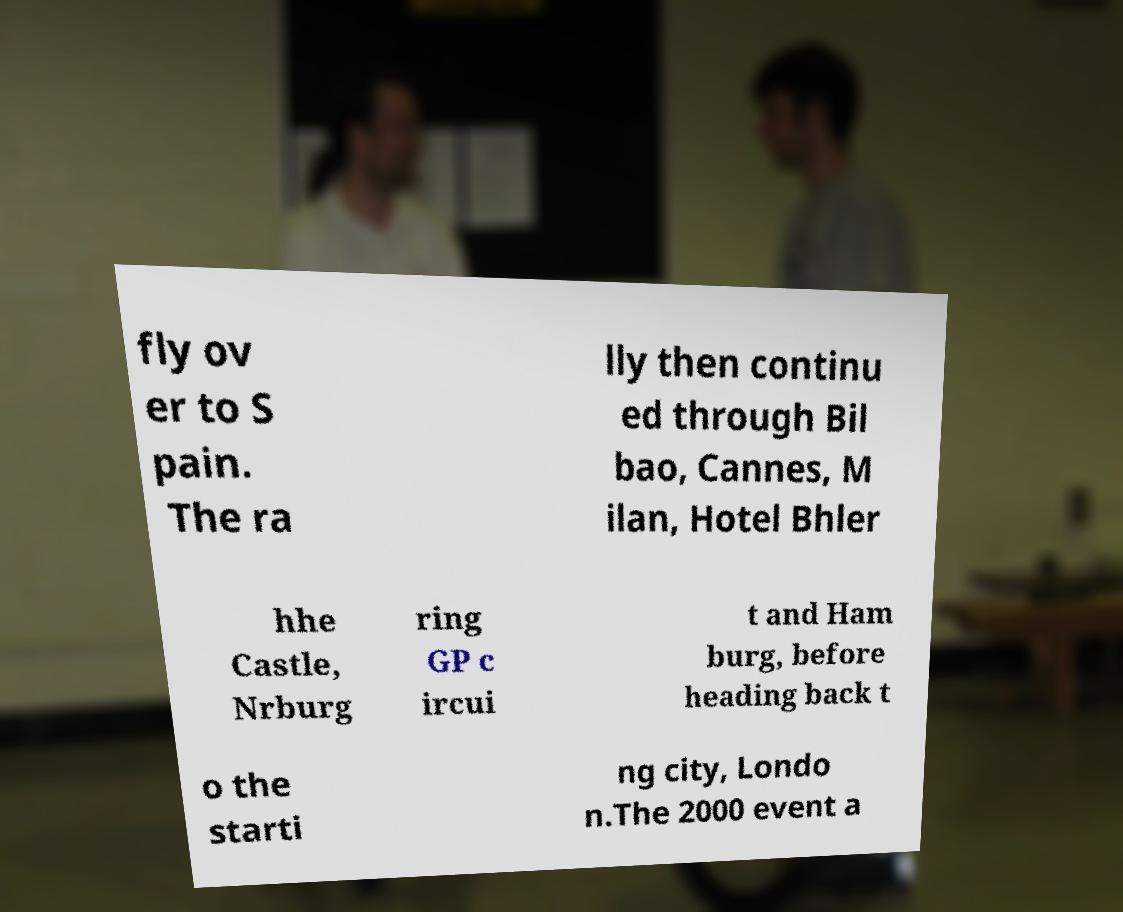Could you extract and type out the text from this image? fly ov er to S pain. The ra lly then continu ed through Bil bao, Cannes, M ilan, Hotel Bhler hhe Castle, Nrburg ring GP c ircui t and Ham burg, before heading back t o the starti ng city, Londo n.The 2000 event a 